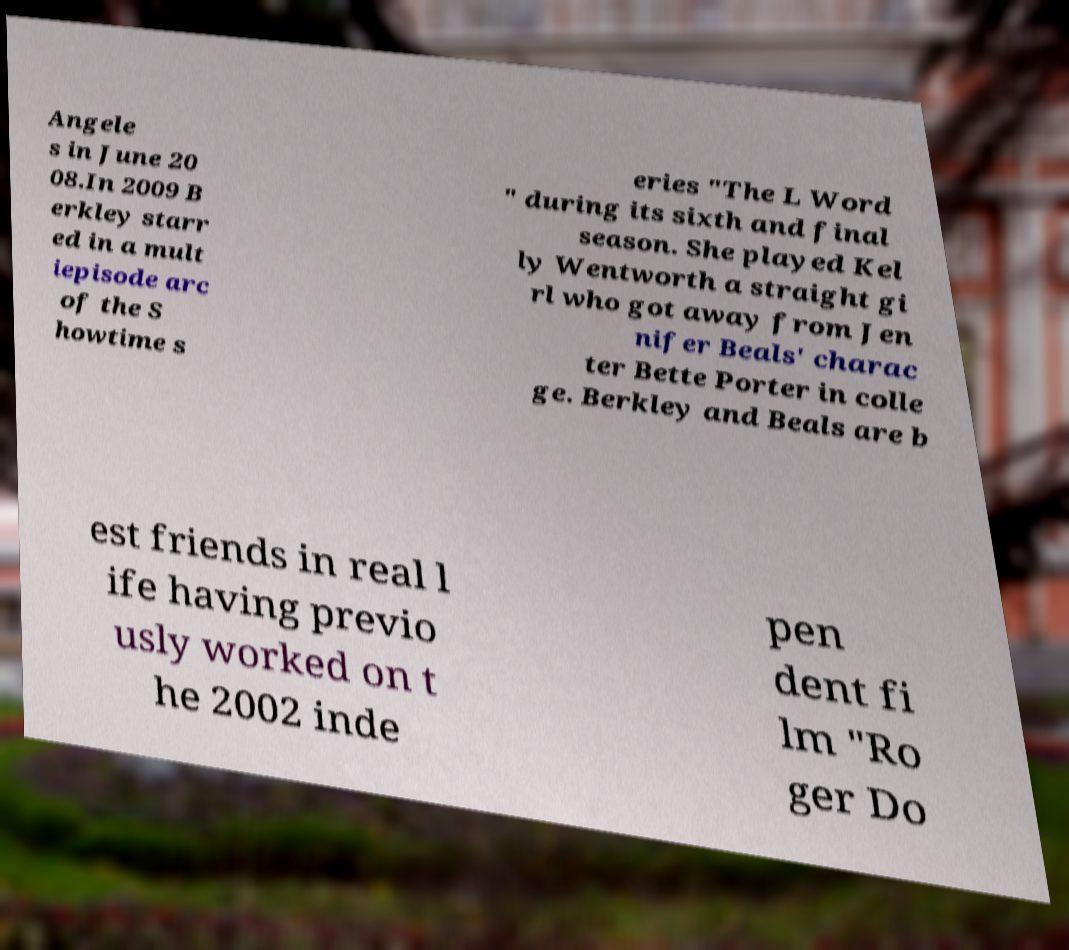Could you assist in decoding the text presented in this image and type it out clearly? Angele s in June 20 08.In 2009 B erkley starr ed in a mult iepisode arc of the S howtime s eries "The L Word " during its sixth and final season. She played Kel ly Wentworth a straight gi rl who got away from Jen nifer Beals' charac ter Bette Porter in colle ge. Berkley and Beals are b est friends in real l ife having previo usly worked on t he 2002 inde pen dent fi lm "Ro ger Do 